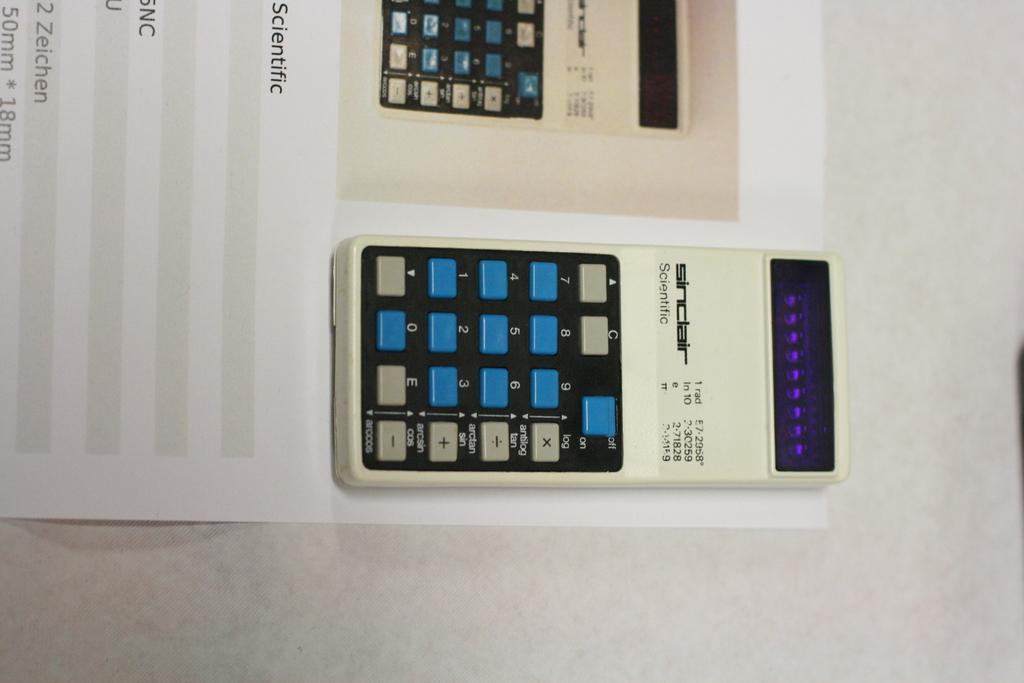Provide a one-sentence caption for the provided image. A Sinclair scientific calculator is resting on its manual. 